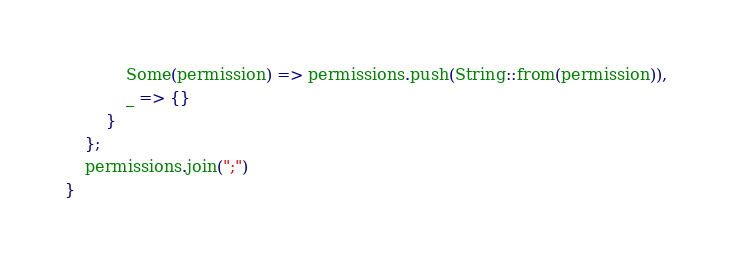Convert code to text. <code><loc_0><loc_0><loc_500><loc_500><_Rust_>            Some(permission) => permissions.push(String::from(permission)),
            _ => {}
        }
    };
    permissions.join(";")
}
</code> 